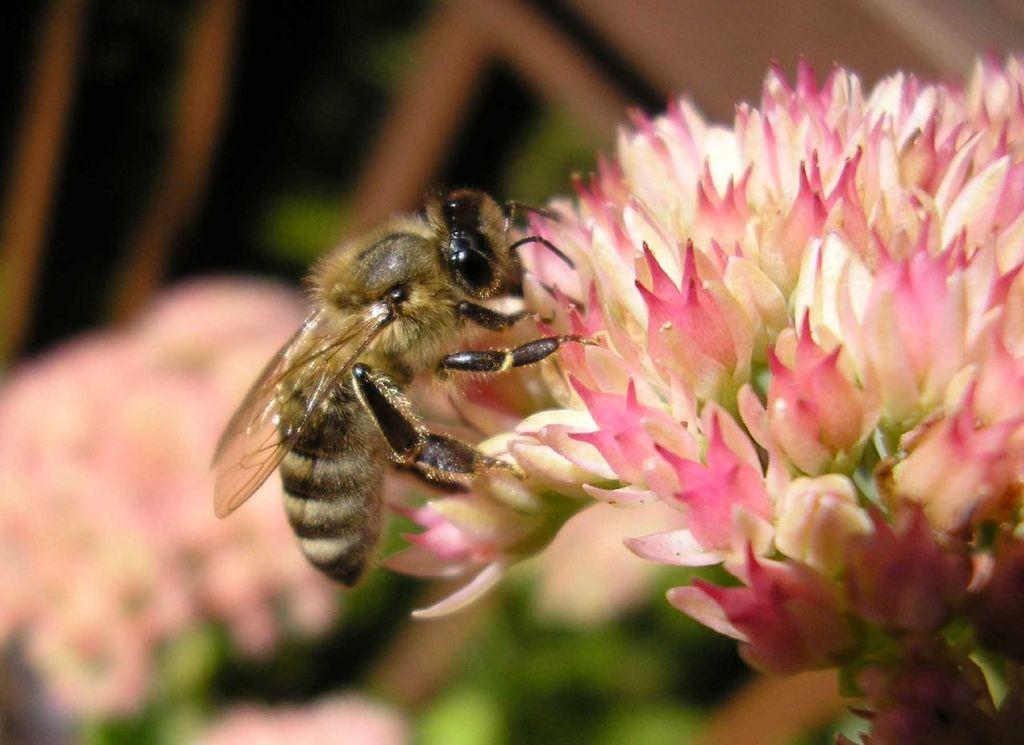What is present on the flower in the image? There is an insect on the flower in the image. What colors can be seen on the insect? The insect has brown and black colors. What colors are present on the flower? The flower has pink and white colors. How would you describe the background of the image? The background of the image is blurred. What type of box can be seen on the insect's feet in the image? There is no box or feet present on the insect in the image. How does the insect's behavior change when it encounters the flower in the image? The image does not show the insect's behavior or any interaction with the flower. 